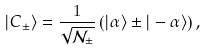Convert formula to latex. <formula><loc_0><loc_0><loc_500><loc_500>| C _ { \pm } \rangle = \frac { 1 } { \sqrt { \mathcal { N } _ { \pm } } } \left ( | \alpha \rangle \pm | - \alpha \rangle \right ) ,</formula> 